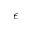<formula> <loc_0><loc_0><loc_500><loc_500>\epsilon</formula> 